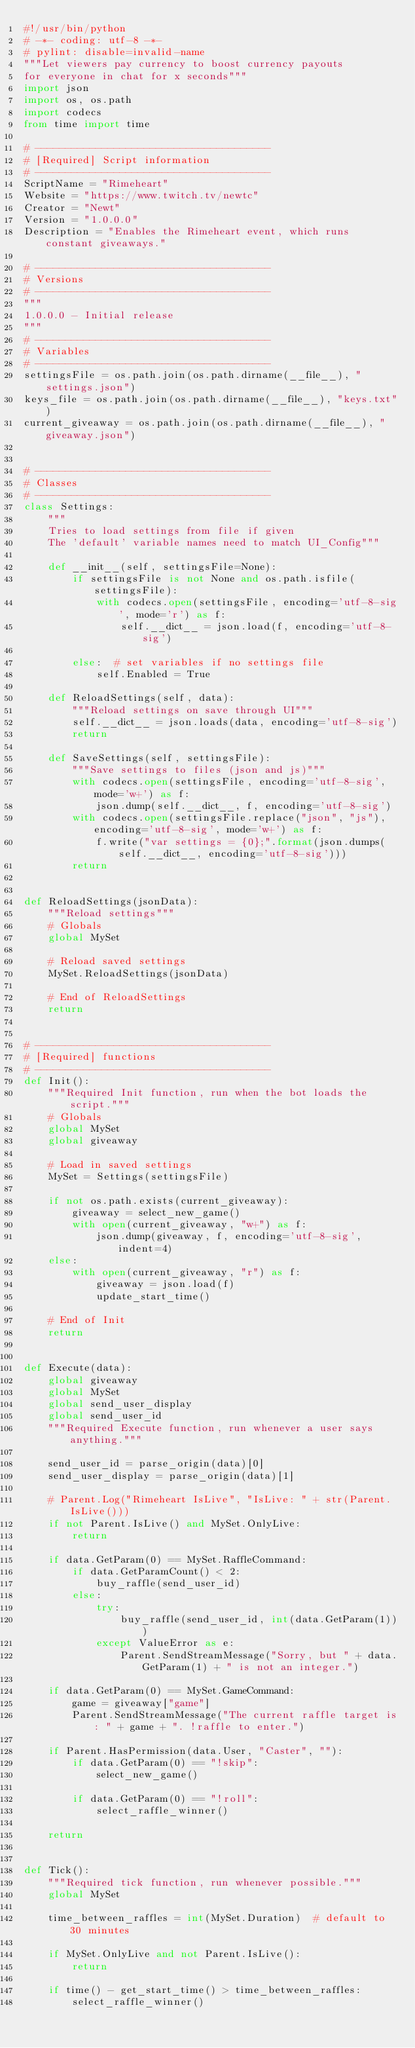<code> <loc_0><loc_0><loc_500><loc_500><_Python_>#!/usr/bin/python
# -*- coding: utf-8 -*-
# pylint: disable=invalid-name
"""Let viewers pay currency to boost currency payouts
for everyone in chat for x seconds"""
import json
import os, os.path
import codecs
from time import time

# ---------------------------------------
# [Required] Script information
# ---------------------------------------
ScriptName = "Rimeheart"
Website = "https://www.twitch.tv/newtc"
Creator = "Newt"
Version = "1.0.0.0"
Description = "Enables the Rimeheart event, which runs constant giveaways."

# ---------------------------------------
# Versions
# ---------------------------------------
"""
1.0.0.0 - Initial release
"""
# ---------------------------------------
# Variables
# ---------------------------------------
settingsFile = os.path.join(os.path.dirname(__file__), "settings.json")
keys_file = os.path.join(os.path.dirname(__file__), "keys.txt")
current_giveaway = os.path.join(os.path.dirname(__file__), "giveaway.json")


# ---------------------------------------
# Classes
# ---------------------------------------
class Settings:
    """
    Tries to load settings from file if given
    The 'default' variable names need to match UI_Config"""

    def __init__(self, settingsFile=None):
        if settingsFile is not None and os.path.isfile(settingsFile):
            with codecs.open(settingsFile, encoding='utf-8-sig', mode='r') as f:
                self.__dict__ = json.load(f, encoding='utf-8-sig')

        else:  # set variables if no settings file
            self.Enabled = True

    def ReloadSettings(self, data):
        """Reload settings on save through UI"""
        self.__dict__ = json.loads(data, encoding='utf-8-sig')
        return

    def SaveSettings(self, settingsFile):
        """Save settings to files (json and js)"""
        with codecs.open(settingsFile, encoding='utf-8-sig', mode='w+') as f:
            json.dump(self.__dict__, f, encoding='utf-8-sig')
        with codecs.open(settingsFile.replace("json", "js"), encoding='utf-8-sig', mode='w+') as f:
            f.write("var settings = {0};".format(json.dumps(self.__dict__, encoding='utf-8-sig')))
        return


def ReloadSettings(jsonData):
    """Reload settings"""
    # Globals
    global MySet

    # Reload saved settings
    MySet.ReloadSettings(jsonData)

    # End of ReloadSettings
    return


# ---------------------------------------
# [Required] functions
# ---------------------------------------
def Init():
    """Required Init function, run when the bot loads the script."""
    # Globals
    global MySet
    global giveaway

    # Load in saved settings
    MySet = Settings(settingsFile)

    if not os.path.exists(current_giveaway):
        giveaway = select_new_game()
        with open(current_giveaway, "w+") as f:
            json.dump(giveaway, f, encoding='utf-8-sig', indent=4)
    else:
        with open(current_giveaway, "r") as f:
            giveaway = json.load(f)
            update_start_time()

    # End of Init
    return


def Execute(data):
    global giveaway
    global MySet
    global send_user_display
    global send_user_id
    """Required Execute function, run whenever a user says anything."""

    send_user_id = parse_origin(data)[0]
    send_user_display = parse_origin(data)[1]

    # Parent.Log("Rimeheart IsLive", "IsLive: " + str(Parent.IsLive()))
    if not Parent.IsLive() and MySet.OnlyLive:
        return

    if data.GetParam(0) == MySet.RaffleCommand:
        if data.GetParamCount() < 2:
            buy_raffle(send_user_id)
        else:
            try:
                buy_raffle(send_user_id, int(data.GetParam(1)))
            except ValueError as e:
                Parent.SendStreamMessage("Sorry, but " + data.GetParam(1) + " is not an integer.")

    if data.GetParam(0) == MySet.GameCommand:
        game = giveaway["game"]
        Parent.SendStreamMessage("The current raffle target is: " + game + ". !raffle to enter.")

    if Parent.HasPermission(data.User, "Caster", ""):
        if data.GetParam(0) == "!skip":
            select_new_game()

        if data.GetParam(0) == "!roll":
            select_raffle_winner()

    return


def Tick():
    """Required tick function, run whenever possible."""
    global MySet

    time_between_raffles = int(MySet.Duration)  # default to 30 minutes

    if MySet.OnlyLive and not Parent.IsLive():
        return

    if time() - get_start_time() > time_between_raffles:
        select_raffle_winner()</code> 